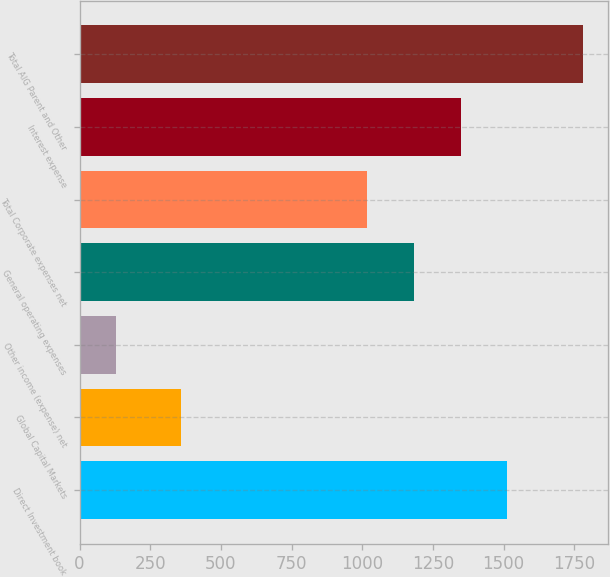<chart> <loc_0><loc_0><loc_500><loc_500><bar_chart><fcel>Direct Investment book<fcel>Global Capital Markets<fcel>Other income (expense) net<fcel>General operating expenses<fcel>Total Corporate expenses net<fcel>Interest expense<fcel>Total AIG Parent and Other<nl><fcel>1513.6<fcel>359<fcel>128<fcel>1183.2<fcel>1018<fcel>1348.4<fcel>1780<nl></chart> 